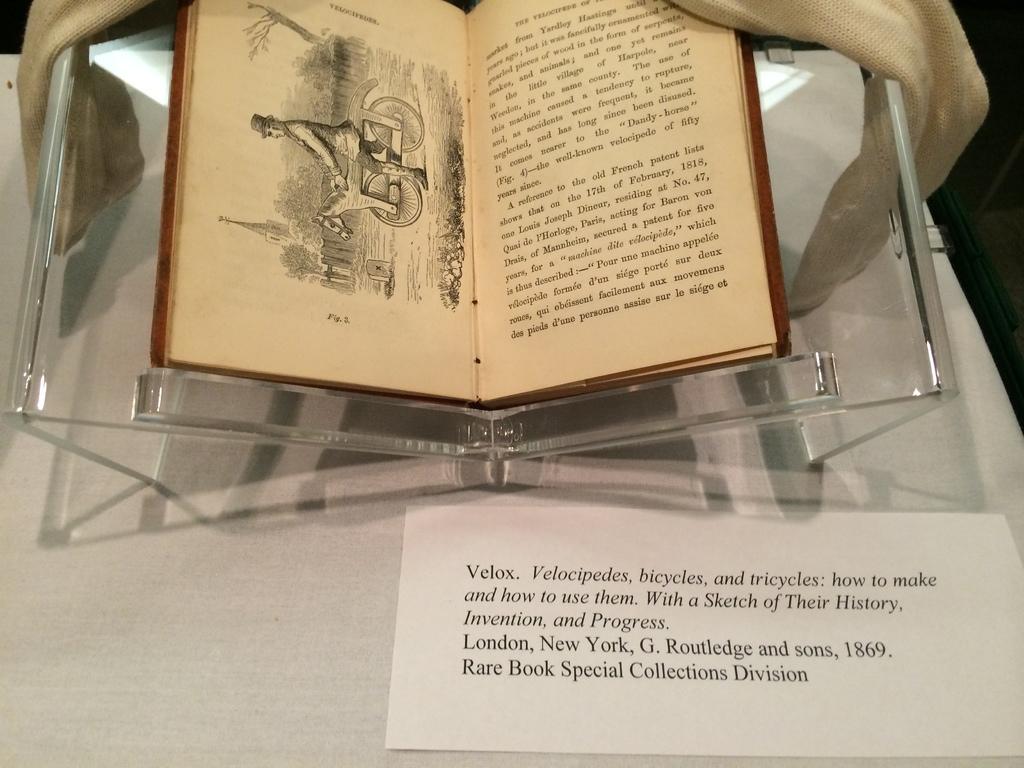When was this book written?
Ensure brevity in your answer.  1869. Who is the author?
Your answer should be compact. G. routledge and sons. 